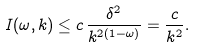<formula> <loc_0><loc_0><loc_500><loc_500>I ( \omega , k ) \leq c \, \frac { \delta ^ { 2 } } { k ^ { 2 ( 1 - \omega ) } } = \frac { c } { k ^ { 2 } } .</formula> 